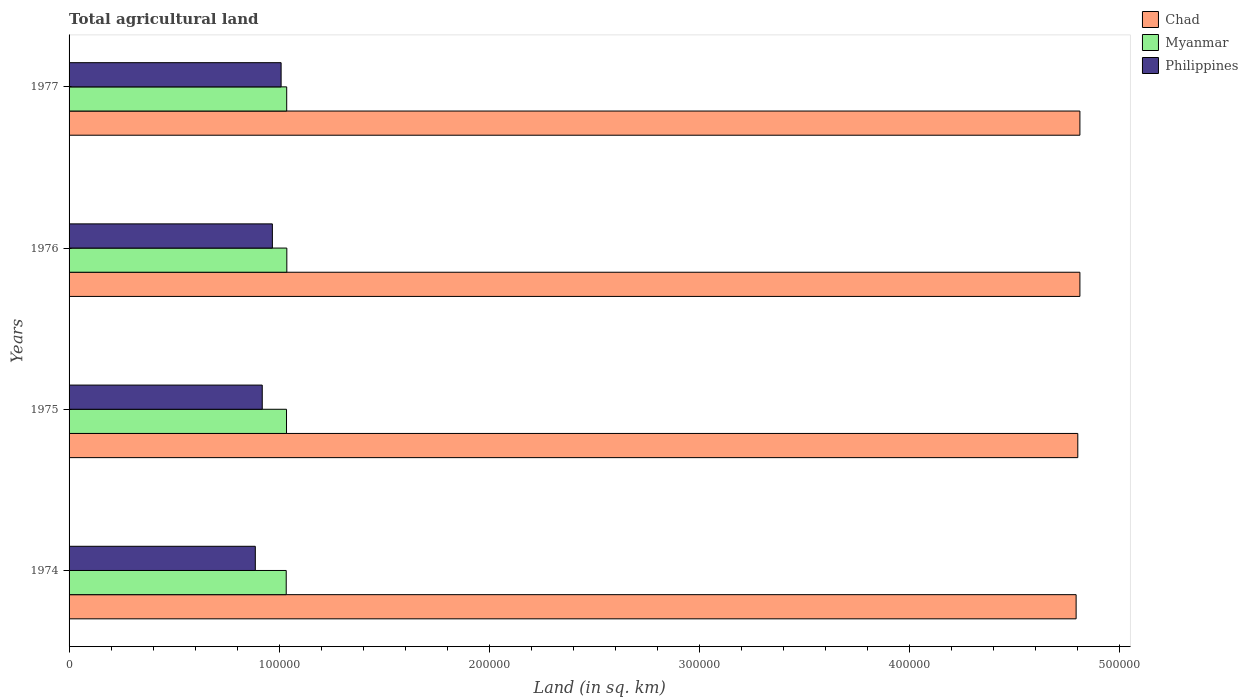How many different coloured bars are there?
Ensure brevity in your answer.  3. How many groups of bars are there?
Offer a terse response. 4. Are the number of bars per tick equal to the number of legend labels?
Your response must be concise. Yes. How many bars are there on the 3rd tick from the bottom?
Your answer should be compact. 3. What is the label of the 1st group of bars from the top?
Offer a very short reply. 1977. In how many cases, is the number of bars for a given year not equal to the number of legend labels?
Provide a succinct answer. 0. What is the total agricultural land in Chad in 1974?
Offer a very short reply. 4.79e+05. Across all years, what is the maximum total agricultural land in Philippines?
Your response must be concise. 1.01e+05. Across all years, what is the minimum total agricultural land in Myanmar?
Your answer should be compact. 1.03e+05. In which year was the total agricultural land in Chad maximum?
Offer a very short reply. 1976. In which year was the total agricultural land in Philippines minimum?
Give a very brief answer. 1974. What is the total total agricultural land in Chad in the graph?
Your response must be concise. 1.92e+06. What is the difference between the total agricultural land in Myanmar in 1976 and that in 1977?
Your answer should be compact. 60. What is the difference between the total agricultural land in Philippines in 1977 and the total agricultural land in Myanmar in 1975?
Give a very brief answer. -2570. What is the average total agricultural land in Myanmar per year?
Offer a very short reply. 1.03e+05. In the year 1975, what is the difference between the total agricultural land in Myanmar and total agricultural land in Chad?
Provide a succinct answer. -3.77e+05. What is the ratio of the total agricultural land in Philippines in 1974 to that in 1977?
Keep it short and to the point. 0.88. Is the total agricultural land in Philippines in 1975 less than that in 1977?
Your response must be concise. Yes. Is the difference between the total agricultural land in Myanmar in 1975 and 1976 greater than the difference between the total agricultural land in Chad in 1975 and 1976?
Your answer should be very brief. Yes. What is the difference between the highest and the lowest total agricultural land in Philippines?
Offer a very short reply. 1.23e+04. Is the sum of the total agricultural land in Philippines in 1974 and 1976 greater than the maximum total agricultural land in Myanmar across all years?
Offer a terse response. Yes. What does the 1st bar from the top in 1974 represents?
Give a very brief answer. Philippines. What does the 2nd bar from the bottom in 1975 represents?
Ensure brevity in your answer.  Myanmar. Is it the case that in every year, the sum of the total agricultural land in Chad and total agricultural land in Myanmar is greater than the total agricultural land in Philippines?
Give a very brief answer. Yes. What is the difference between two consecutive major ticks on the X-axis?
Ensure brevity in your answer.  1.00e+05. Does the graph contain grids?
Ensure brevity in your answer.  No. Where does the legend appear in the graph?
Provide a short and direct response. Top right. How many legend labels are there?
Offer a terse response. 3. What is the title of the graph?
Provide a short and direct response. Total agricultural land. Does "Cameroon" appear as one of the legend labels in the graph?
Offer a terse response. No. What is the label or title of the X-axis?
Give a very brief answer. Land (in sq. km). What is the label or title of the Y-axis?
Your answer should be very brief. Years. What is the Land (in sq. km) in Chad in 1974?
Your response must be concise. 4.79e+05. What is the Land (in sq. km) in Myanmar in 1974?
Your answer should be very brief. 1.03e+05. What is the Land (in sq. km) in Philippines in 1974?
Your response must be concise. 8.86e+04. What is the Land (in sq. km) of Chad in 1975?
Provide a succinct answer. 4.80e+05. What is the Land (in sq. km) in Myanmar in 1975?
Make the answer very short. 1.03e+05. What is the Land (in sq. km) in Philippines in 1975?
Ensure brevity in your answer.  9.19e+04. What is the Land (in sq. km) of Chad in 1976?
Ensure brevity in your answer.  4.81e+05. What is the Land (in sq. km) of Myanmar in 1976?
Provide a short and direct response. 1.04e+05. What is the Land (in sq. km) in Philippines in 1976?
Make the answer very short. 9.67e+04. What is the Land (in sq. km) of Chad in 1977?
Offer a terse response. 4.81e+05. What is the Land (in sq. km) of Myanmar in 1977?
Make the answer very short. 1.04e+05. What is the Land (in sq. km) of Philippines in 1977?
Provide a short and direct response. 1.01e+05. Across all years, what is the maximum Land (in sq. km) of Chad?
Give a very brief answer. 4.81e+05. Across all years, what is the maximum Land (in sq. km) of Myanmar?
Give a very brief answer. 1.04e+05. Across all years, what is the maximum Land (in sq. km) in Philippines?
Your response must be concise. 1.01e+05. Across all years, what is the minimum Land (in sq. km) in Chad?
Offer a very short reply. 4.79e+05. Across all years, what is the minimum Land (in sq. km) in Myanmar?
Give a very brief answer. 1.03e+05. Across all years, what is the minimum Land (in sq. km) in Philippines?
Offer a very short reply. 8.86e+04. What is the total Land (in sq. km) of Chad in the graph?
Your answer should be very brief. 1.92e+06. What is the total Land (in sq. km) in Myanmar in the graph?
Offer a very short reply. 4.14e+05. What is the total Land (in sq. km) of Philippines in the graph?
Give a very brief answer. 3.78e+05. What is the difference between the Land (in sq. km) of Chad in 1974 and that in 1975?
Offer a terse response. -800. What is the difference between the Land (in sq. km) of Myanmar in 1974 and that in 1975?
Provide a short and direct response. -140. What is the difference between the Land (in sq. km) in Philippines in 1974 and that in 1975?
Provide a short and direct response. -3300. What is the difference between the Land (in sq. km) of Chad in 1974 and that in 1976?
Ensure brevity in your answer.  -1800. What is the difference between the Land (in sq. km) in Myanmar in 1974 and that in 1976?
Offer a very short reply. -290. What is the difference between the Land (in sq. km) in Philippines in 1974 and that in 1976?
Keep it short and to the point. -8120. What is the difference between the Land (in sq. km) of Chad in 1974 and that in 1977?
Offer a very short reply. -1800. What is the difference between the Land (in sq. km) in Myanmar in 1974 and that in 1977?
Provide a succinct answer. -230. What is the difference between the Land (in sq. km) of Philippines in 1974 and that in 1977?
Keep it short and to the point. -1.23e+04. What is the difference between the Land (in sq. km) of Chad in 1975 and that in 1976?
Provide a short and direct response. -1000. What is the difference between the Land (in sq. km) in Myanmar in 1975 and that in 1976?
Make the answer very short. -150. What is the difference between the Land (in sq. km) in Philippines in 1975 and that in 1976?
Provide a succinct answer. -4820. What is the difference between the Land (in sq. km) in Chad in 1975 and that in 1977?
Ensure brevity in your answer.  -1000. What is the difference between the Land (in sq. km) of Myanmar in 1975 and that in 1977?
Offer a very short reply. -90. What is the difference between the Land (in sq. km) in Philippines in 1975 and that in 1977?
Make the answer very short. -8980. What is the difference between the Land (in sq. km) of Philippines in 1976 and that in 1977?
Your answer should be compact. -4160. What is the difference between the Land (in sq. km) in Chad in 1974 and the Land (in sq. km) in Myanmar in 1975?
Keep it short and to the point. 3.76e+05. What is the difference between the Land (in sq. km) in Chad in 1974 and the Land (in sq. km) in Philippines in 1975?
Your answer should be compact. 3.87e+05. What is the difference between the Land (in sq. km) of Myanmar in 1974 and the Land (in sq. km) of Philippines in 1975?
Offer a terse response. 1.14e+04. What is the difference between the Land (in sq. km) of Chad in 1974 and the Land (in sq. km) of Myanmar in 1976?
Your answer should be very brief. 3.76e+05. What is the difference between the Land (in sq. km) in Chad in 1974 and the Land (in sq. km) in Philippines in 1976?
Give a very brief answer. 3.82e+05. What is the difference between the Land (in sq. km) of Myanmar in 1974 and the Land (in sq. km) of Philippines in 1976?
Ensure brevity in your answer.  6590. What is the difference between the Land (in sq. km) of Chad in 1974 and the Land (in sq. km) of Myanmar in 1977?
Offer a very short reply. 3.76e+05. What is the difference between the Land (in sq. km) of Chad in 1974 and the Land (in sq. km) of Philippines in 1977?
Make the answer very short. 3.78e+05. What is the difference between the Land (in sq. km) in Myanmar in 1974 and the Land (in sq. km) in Philippines in 1977?
Give a very brief answer. 2430. What is the difference between the Land (in sq. km) of Chad in 1975 and the Land (in sq. km) of Myanmar in 1976?
Keep it short and to the point. 3.76e+05. What is the difference between the Land (in sq. km) in Chad in 1975 and the Land (in sq. km) in Philippines in 1976?
Offer a terse response. 3.83e+05. What is the difference between the Land (in sq. km) in Myanmar in 1975 and the Land (in sq. km) in Philippines in 1976?
Give a very brief answer. 6730. What is the difference between the Land (in sq. km) in Chad in 1975 and the Land (in sq. km) in Myanmar in 1977?
Make the answer very short. 3.76e+05. What is the difference between the Land (in sq. km) of Chad in 1975 and the Land (in sq. km) of Philippines in 1977?
Keep it short and to the point. 3.79e+05. What is the difference between the Land (in sq. km) of Myanmar in 1975 and the Land (in sq. km) of Philippines in 1977?
Your answer should be compact. 2570. What is the difference between the Land (in sq. km) in Chad in 1976 and the Land (in sq. km) in Myanmar in 1977?
Keep it short and to the point. 3.77e+05. What is the difference between the Land (in sq. km) of Chad in 1976 and the Land (in sq. km) of Philippines in 1977?
Provide a short and direct response. 3.80e+05. What is the difference between the Land (in sq. km) in Myanmar in 1976 and the Land (in sq. km) in Philippines in 1977?
Keep it short and to the point. 2720. What is the average Land (in sq. km) in Chad per year?
Provide a succinct answer. 4.80e+05. What is the average Land (in sq. km) of Myanmar per year?
Provide a short and direct response. 1.03e+05. What is the average Land (in sq. km) in Philippines per year?
Provide a short and direct response. 9.45e+04. In the year 1974, what is the difference between the Land (in sq. km) of Chad and Land (in sq. km) of Myanmar?
Your response must be concise. 3.76e+05. In the year 1974, what is the difference between the Land (in sq. km) of Chad and Land (in sq. km) of Philippines?
Your answer should be compact. 3.91e+05. In the year 1974, what is the difference between the Land (in sq. km) of Myanmar and Land (in sq. km) of Philippines?
Ensure brevity in your answer.  1.47e+04. In the year 1975, what is the difference between the Land (in sq. km) of Chad and Land (in sq. km) of Myanmar?
Make the answer very short. 3.77e+05. In the year 1975, what is the difference between the Land (in sq. km) in Chad and Land (in sq. km) in Philippines?
Your response must be concise. 3.88e+05. In the year 1975, what is the difference between the Land (in sq. km) of Myanmar and Land (in sq. km) of Philippines?
Offer a terse response. 1.16e+04. In the year 1976, what is the difference between the Land (in sq. km) of Chad and Land (in sq. km) of Myanmar?
Provide a succinct answer. 3.77e+05. In the year 1976, what is the difference between the Land (in sq. km) in Chad and Land (in sq. km) in Philippines?
Give a very brief answer. 3.84e+05. In the year 1976, what is the difference between the Land (in sq. km) in Myanmar and Land (in sq. km) in Philippines?
Ensure brevity in your answer.  6880. In the year 1977, what is the difference between the Land (in sq. km) in Chad and Land (in sq. km) in Myanmar?
Your answer should be very brief. 3.77e+05. In the year 1977, what is the difference between the Land (in sq. km) in Chad and Land (in sq. km) in Philippines?
Your answer should be compact. 3.80e+05. In the year 1977, what is the difference between the Land (in sq. km) in Myanmar and Land (in sq. km) in Philippines?
Give a very brief answer. 2660. What is the ratio of the Land (in sq. km) in Myanmar in 1974 to that in 1975?
Give a very brief answer. 1. What is the ratio of the Land (in sq. km) in Philippines in 1974 to that in 1975?
Offer a terse response. 0.96. What is the ratio of the Land (in sq. km) in Chad in 1974 to that in 1976?
Your answer should be very brief. 1. What is the ratio of the Land (in sq. km) in Myanmar in 1974 to that in 1976?
Your response must be concise. 1. What is the ratio of the Land (in sq. km) of Philippines in 1974 to that in 1976?
Make the answer very short. 0.92. What is the ratio of the Land (in sq. km) in Chad in 1974 to that in 1977?
Offer a very short reply. 1. What is the ratio of the Land (in sq. km) in Philippines in 1974 to that in 1977?
Provide a succinct answer. 0.88. What is the ratio of the Land (in sq. km) in Myanmar in 1975 to that in 1976?
Your answer should be compact. 1. What is the ratio of the Land (in sq. km) of Philippines in 1975 to that in 1976?
Your response must be concise. 0.95. What is the ratio of the Land (in sq. km) of Chad in 1975 to that in 1977?
Offer a very short reply. 1. What is the ratio of the Land (in sq. km) of Philippines in 1975 to that in 1977?
Your response must be concise. 0.91. What is the ratio of the Land (in sq. km) in Chad in 1976 to that in 1977?
Make the answer very short. 1. What is the ratio of the Land (in sq. km) of Myanmar in 1976 to that in 1977?
Offer a very short reply. 1. What is the ratio of the Land (in sq. km) in Philippines in 1976 to that in 1977?
Ensure brevity in your answer.  0.96. What is the difference between the highest and the second highest Land (in sq. km) in Chad?
Offer a terse response. 0. What is the difference between the highest and the second highest Land (in sq. km) in Myanmar?
Give a very brief answer. 60. What is the difference between the highest and the second highest Land (in sq. km) of Philippines?
Provide a short and direct response. 4160. What is the difference between the highest and the lowest Land (in sq. km) of Chad?
Your answer should be very brief. 1800. What is the difference between the highest and the lowest Land (in sq. km) of Myanmar?
Ensure brevity in your answer.  290. What is the difference between the highest and the lowest Land (in sq. km) in Philippines?
Give a very brief answer. 1.23e+04. 